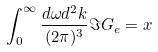Convert formula to latex. <formula><loc_0><loc_0><loc_500><loc_500>\int _ { 0 } ^ { \infty } \frac { d \omega d ^ { 2 } k } { ( 2 \pi ) ^ { 3 } } \Im G _ { e } = x</formula> 